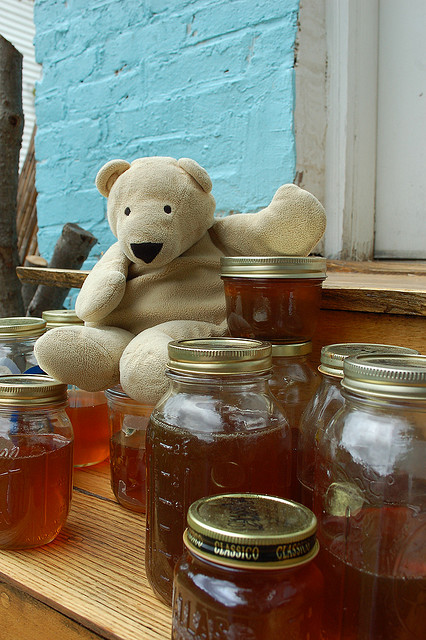Read all the text in this image. CLASSIC 